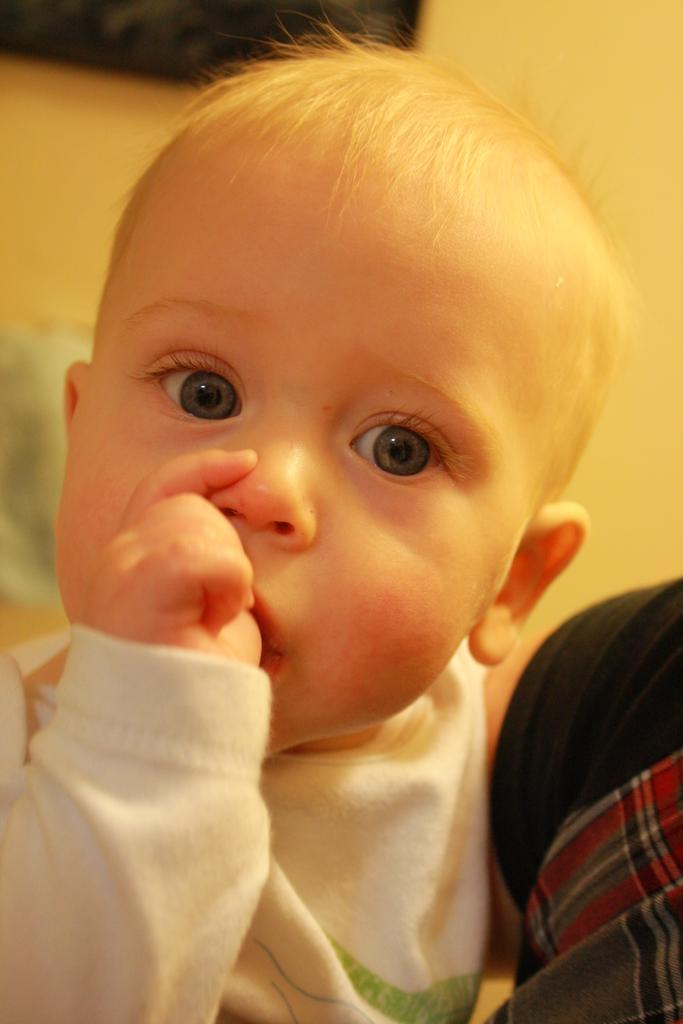What is the main subject of the picture? The main subject of the picture is a kid. What is the kid wearing in the image? The kid is wearing a white T-shirt. What is the kid doing in the image? The kid has placed his thumb finger in his mouth. Can you describe the other person in the image? There is another person in the right corner of the image. What theory is the kid learning from the other person in the image? There is no indication in the image that the kid is learning a theory or engaging in any educational activity with the other person. 